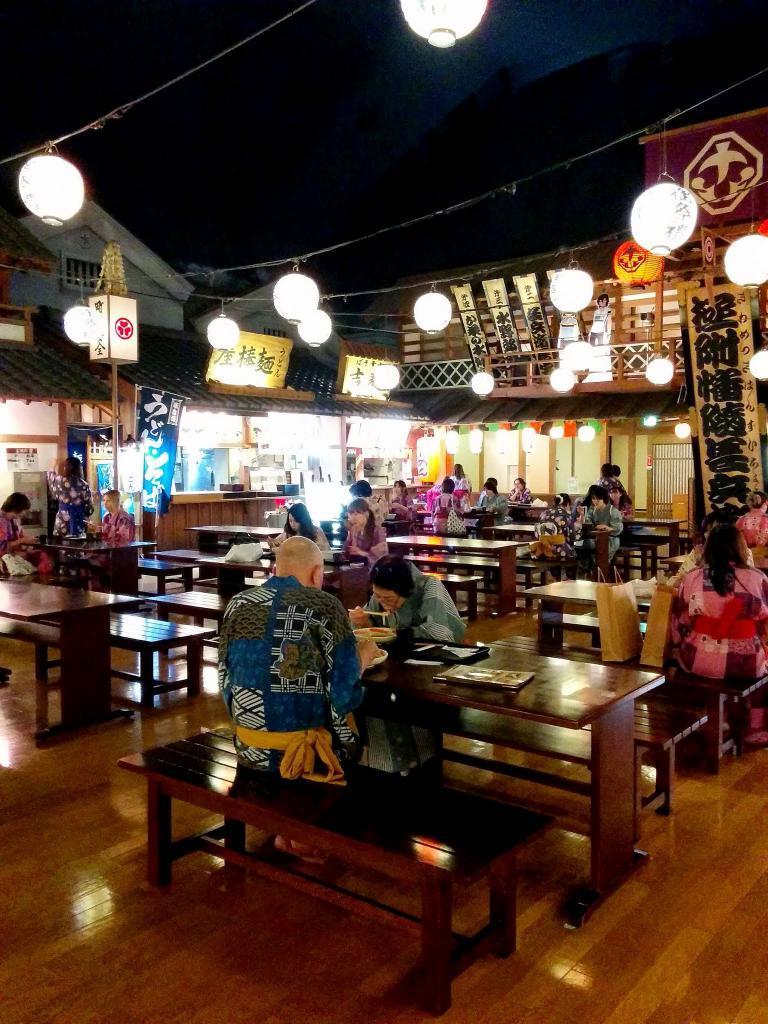Can you describe this image briefly? In this image I can see number of benches and on these benches I can see people are sitting. I can also see lights as decoration and few buildings. 